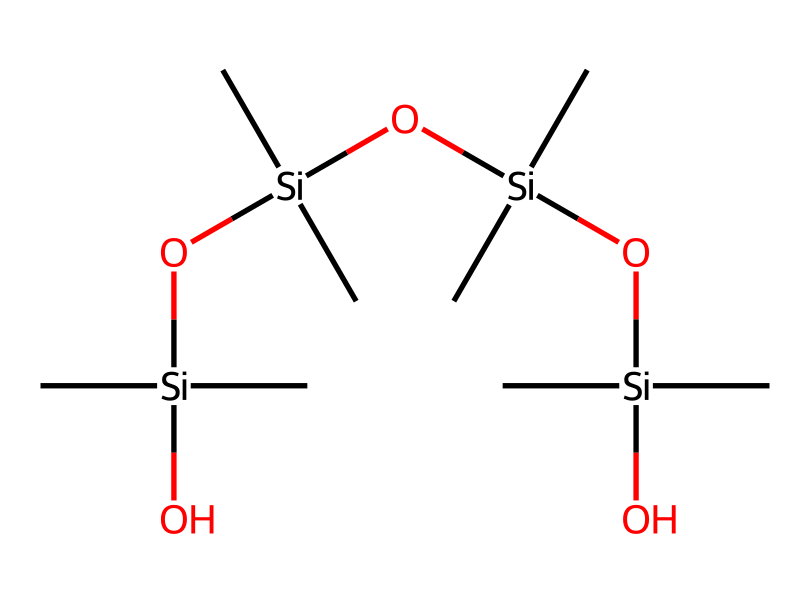What type of polymer is represented in this structure? The structure reflects a polymer made of repeating units known as siloxanes, indicated by the silicon and oxygen alternating in the backbone.
Answer: siloxane How many silicon atoms are present in this molecule? By examining the structure, there is one silicon atom at the start and three additional silicon atoms within the repeating units, totaling four silicon atoms.
Answer: 4 How many oxygen atoms are present in the chain? The structure shows that there are three silicon-oxygen bonds, which means there are three oxygen atoms connecting the silicon atoms in the main chain.
Answer: 3 What is the molecular formula unit of this compound? By interpreting the structure, each repeating unit consists of two methyl groups and one siloxane linkage, thus the compound can be represented by the general molecular formula for polydimethylsiloxane as (C2H6OSi)n.
Answer: (C2H6OSi)n Which groups are attached to the silicon atoms in the structure? The SMILES representation shows that each silicon atom has two methyl groups (C) attached to it, indicating the presence of dimethyl groups in the structure.
Answer: dimethyl groups What is the significance of the siloxane bonds in this compound? The siloxane bonds (Si-O) provide flexibility and thermal stability to the polymer, which is vital for applications in electronics and computer hardware.
Answer: flexibility and thermal stability 